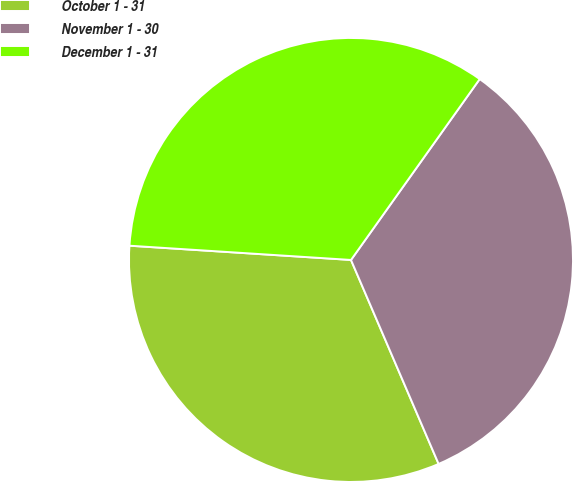<chart> <loc_0><loc_0><loc_500><loc_500><pie_chart><fcel>October 1 - 31<fcel>November 1 - 30<fcel>December 1 - 31<nl><fcel>32.48%<fcel>33.7%<fcel>33.82%<nl></chart> 